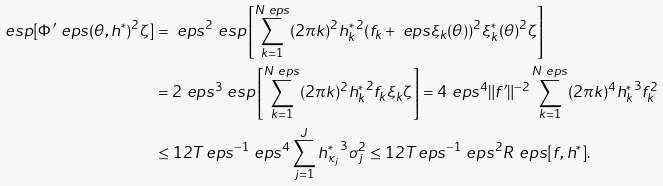Convert formula to latex. <formula><loc_0><loc_0><loc_500><loc_500>\ e s p [ \Phi ^ { \prime } _ { \ } e p s ( \theta , h ^ { * } ) ^ { 2 } \zeta ] & = \ e p s ^ { 2 } \ e s p \left [ \sum _ { k = 1 } ^ { N _ { \ } e p s } ( 2 \pi k ) ^ { 2 } { h _ { k } ^ { * } } ^ { 2 } ( f _ { k } + \ e p s \xi _ { k } ( \theta ) ) ^ { 2 } \xi _ { k } ^ { * } ( \theta ) ^ { 2 } \zeta \right ] \\ & = 2 \ e p s ^ { 3 } \ e s p \left [ \sum _ { k = 1 } ^ { N _ { \ } e p s } ( 2 \pi k ) ^ { 2 } { h _ { k } ^ { * } } ^ { 2 } f _ { k } \xi _ { k } \zeta \right ] = 4 \ e p s ^ { 4 } \| f ^ { \prime } \| ^ { - 2 } \sum _ { k = 1 } ^ { N _ { \ } e p s } ( 2 \pi k ) ^ { 4 } { h _ { k } ^ { * } } ^ { 3 } f _ { k } ^ { 2 } \\ & \leq 1 2 T _ { \ } e p s ^ { - 1 } \ e p s ^ { 4 } \sum _ { j = 1 } ^ { J } { h _ { \kappa _ { j } } ^ { * } } ^ { 3 } \sigma _ { j } ^ { 2 } \leq 1 2 T _ { \ } e p s ^ { - 1 } \ e p s ^ { 2 } R ^ { \ } e p s [ f , h ^ { * } ] .</formula> 